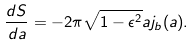<formula> <loc_0><loc_0><loc_500><loc_500>\frac { d S } { d a } = - 2 { \pi } \sqrt { 1 - \epsilon ^ { 2 } } a j _ { b } ( a ) .</formula> 